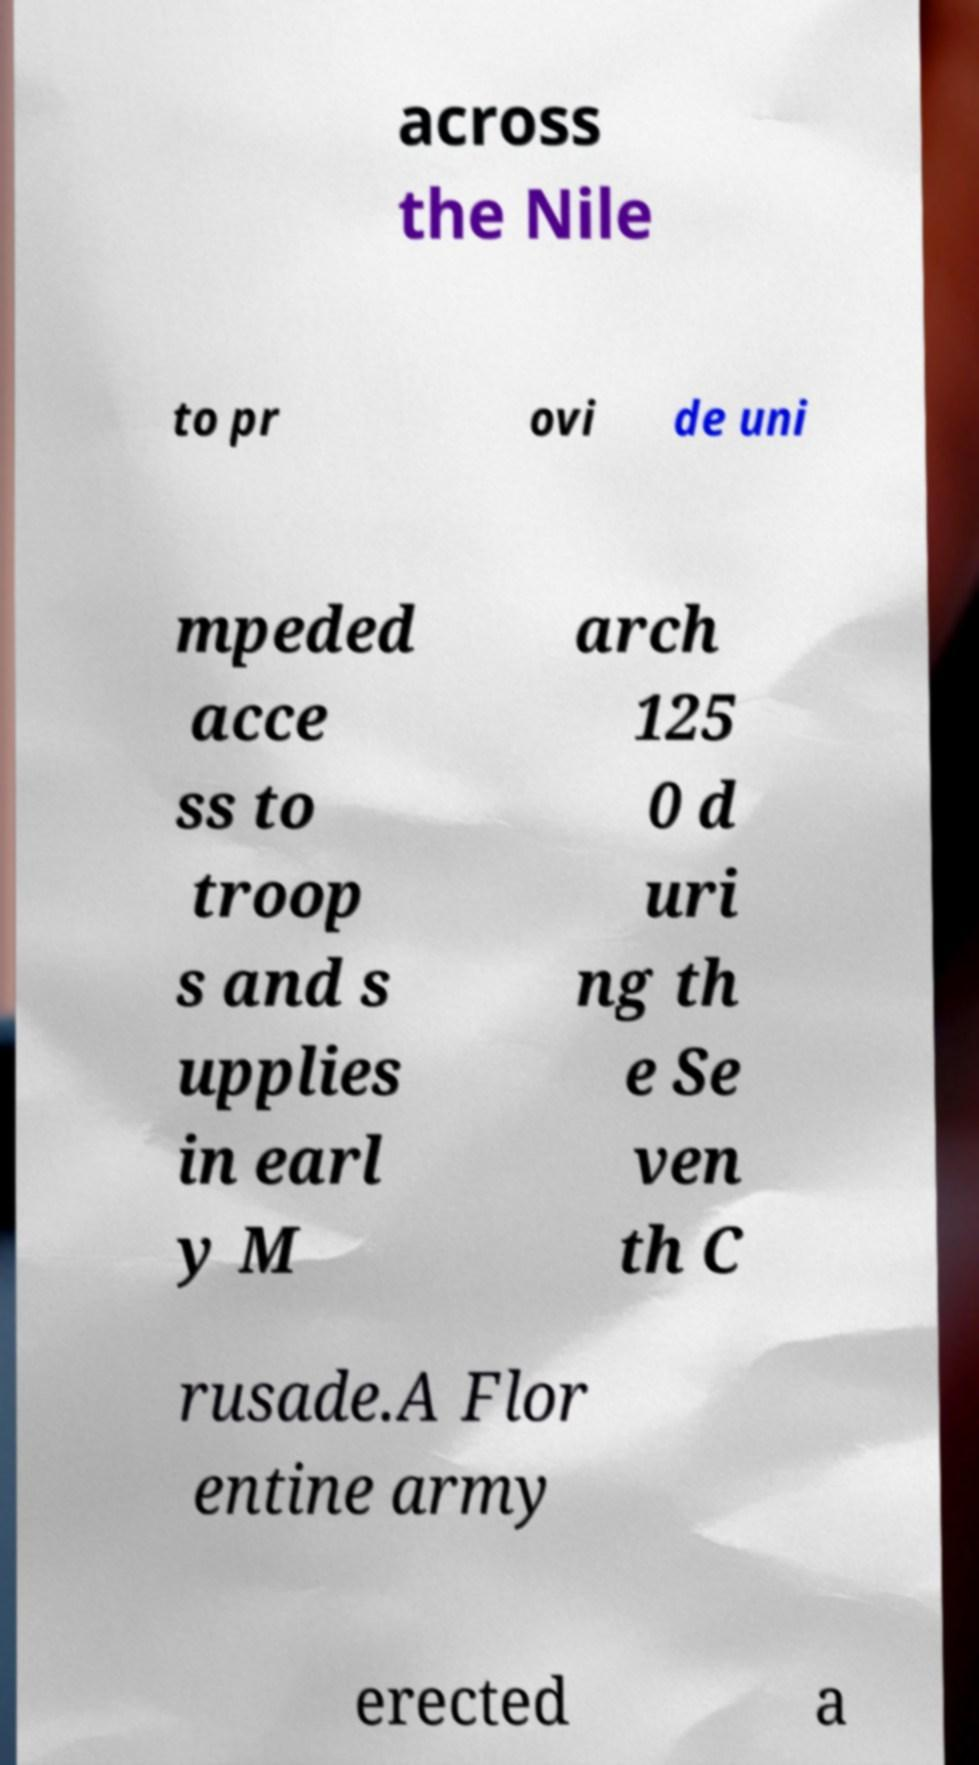For documentation purposes, I need the text within this image transcribed. Could you provide that? across the Nile to pr ovi de uni mpeded acce ss to troop s and s upplies in earl y M arch 125 0 d uri ng th e Se ven th C rusade.A Flor entine army erected a 